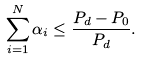Convert formula to latex. <formula><loc_0><loc_0><loc_500><loc_500>\sum _ { i = 1 } ^ { N } \alpha _ { i } \leq \frac { P _ { d } - P _ { 0 } } { P _ { d } } .</formula> 